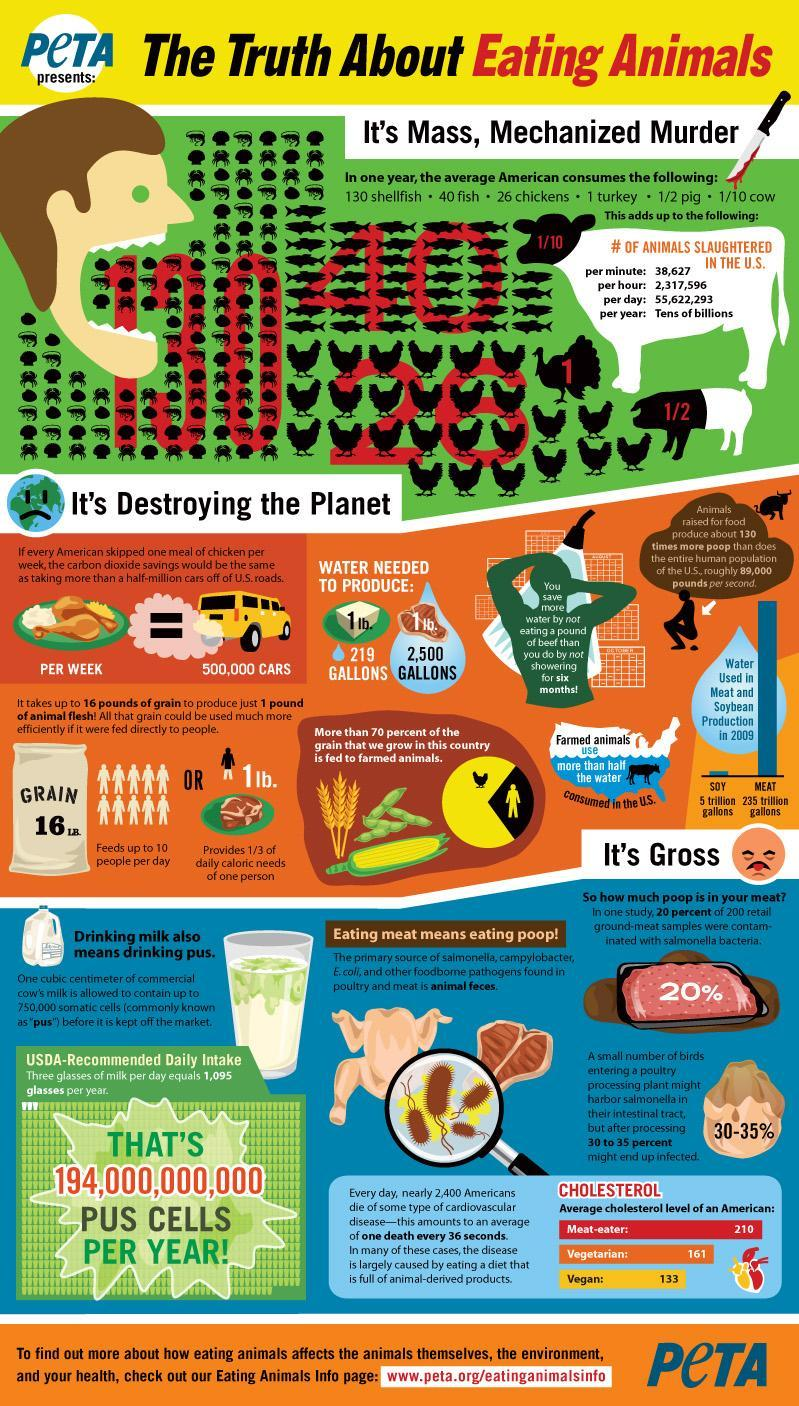What % of grain grown is consumed by the population
Answer the question with a short phrase. 30 How much higher is the cholesterol level of a meat-eater American than a Vegan 77 How much meat intake provided 1/3 of daily caloric needs of one person 1 lb How much water is required to producr 1 lb. of meat 2,500 gallons What is the number written on the head of the cow 1/10 What is the total shell fish, fish and chicken consumed by the average American in a year 196 what is the number written on then body of the pig 1/2 